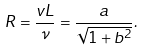Convert formula to latex. <formula><loc_0><loc_0><loc_500><loc_500>R = \frac { v L } { \nu } = \frac { a } { \sqrt { 1 + b ^ { 2 } } } .</formula> 